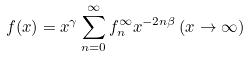Convert formula to latex. <formula><loc_0><loc_0><loc_500><loc_500>f ( x ) = x ^ { \gamma } \sum _ { n = 0 } ^ { \infty } f _ { n } ^ { \infty } x ^ { - 2 n \beta } \, ( x \rightarrow \infty )</formula> 